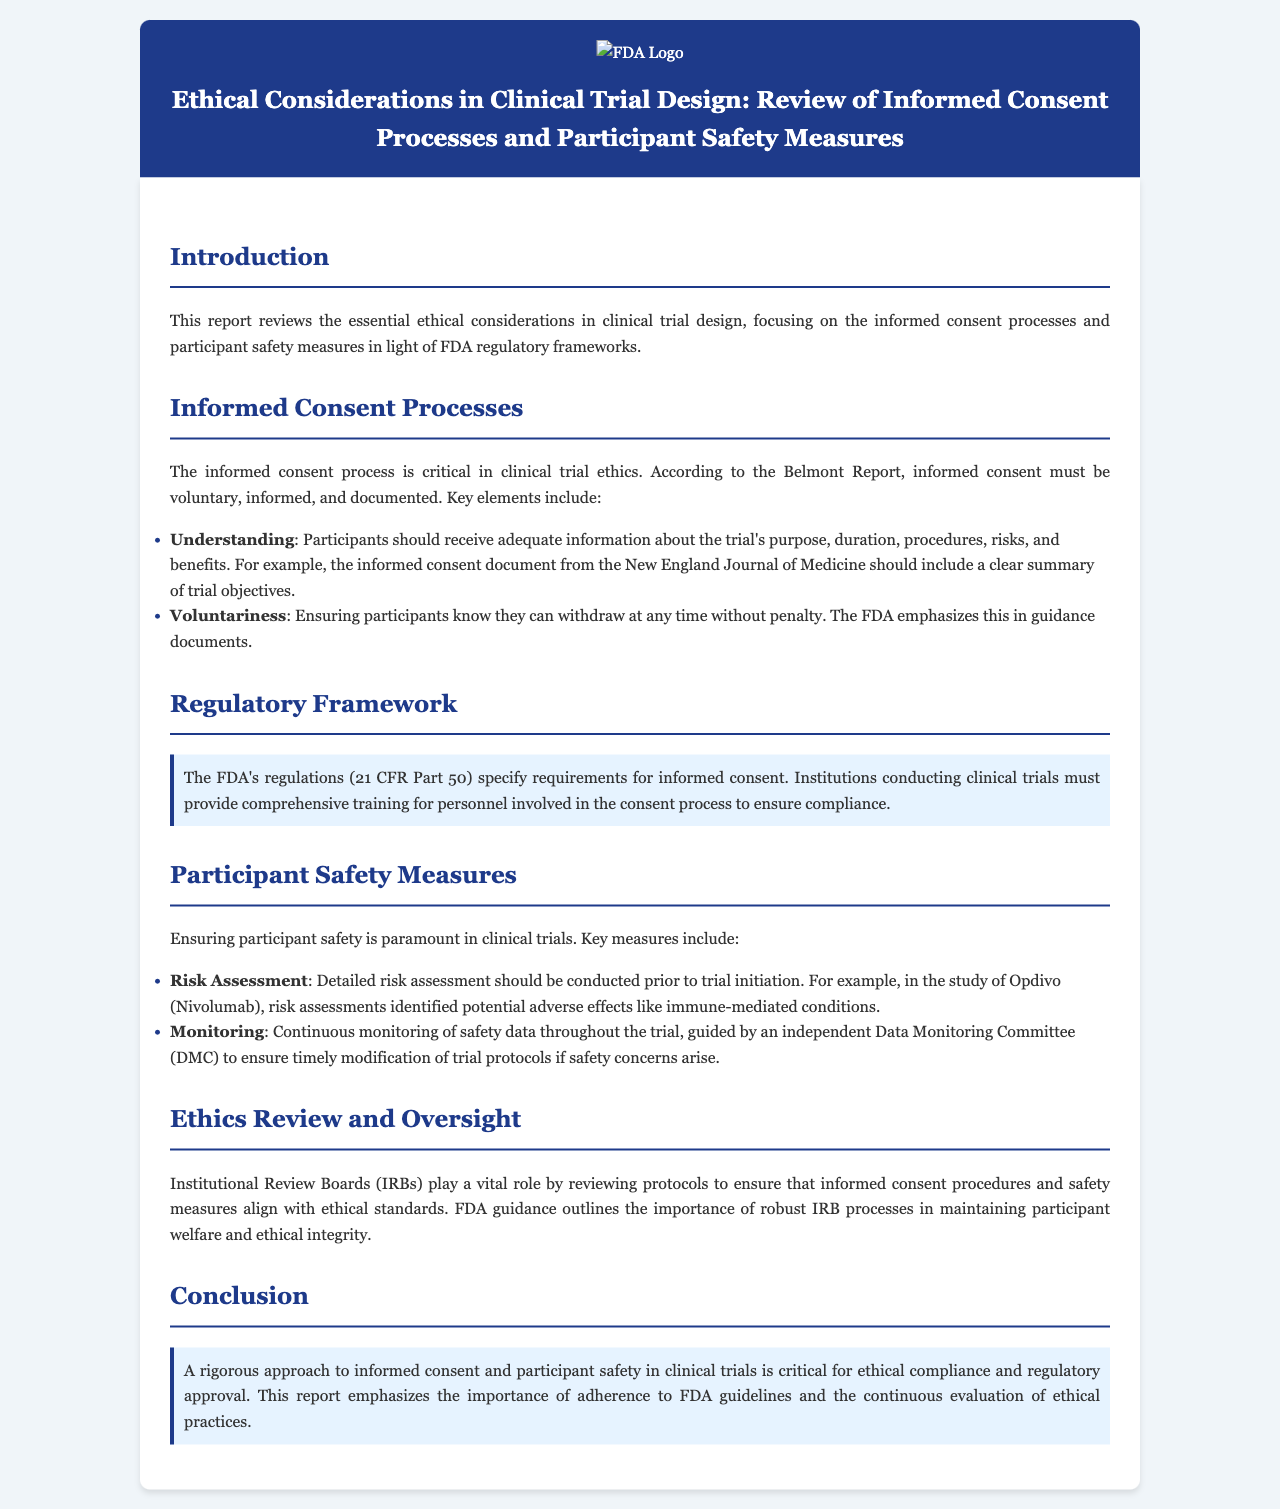What is the title of the report? The title of the report is stated in the header section, which outlines the focus of the document.
Answer: Ethical Considerations in Clinical Trial Design: Review of Informed Consent Processes and Participant Safety Measures What regulatory part specifies requirements for informed consent? The document mentions 21 CFR Part 50 in the section regarding regulatory framework.
Answer: 21 CFR Part 50 Which committee is responsible for monitoring safety data during trials? The report explains that an independent Data Monitoring Committee (DMC) is tasked with this function.
Answer: Data Monitoring Committee What is a key element of informed consent according to the Belmont Report? The document lists several elements, with understanding and voluntariness highlighted as critical parts.
Answer: Understanding What role do Institutional Review Boards play in clinical trials? The document describes that IRBs review protocols to ensure ethical standards are met, indicating their significance in oversight.
Answer: Reviewing protocols 